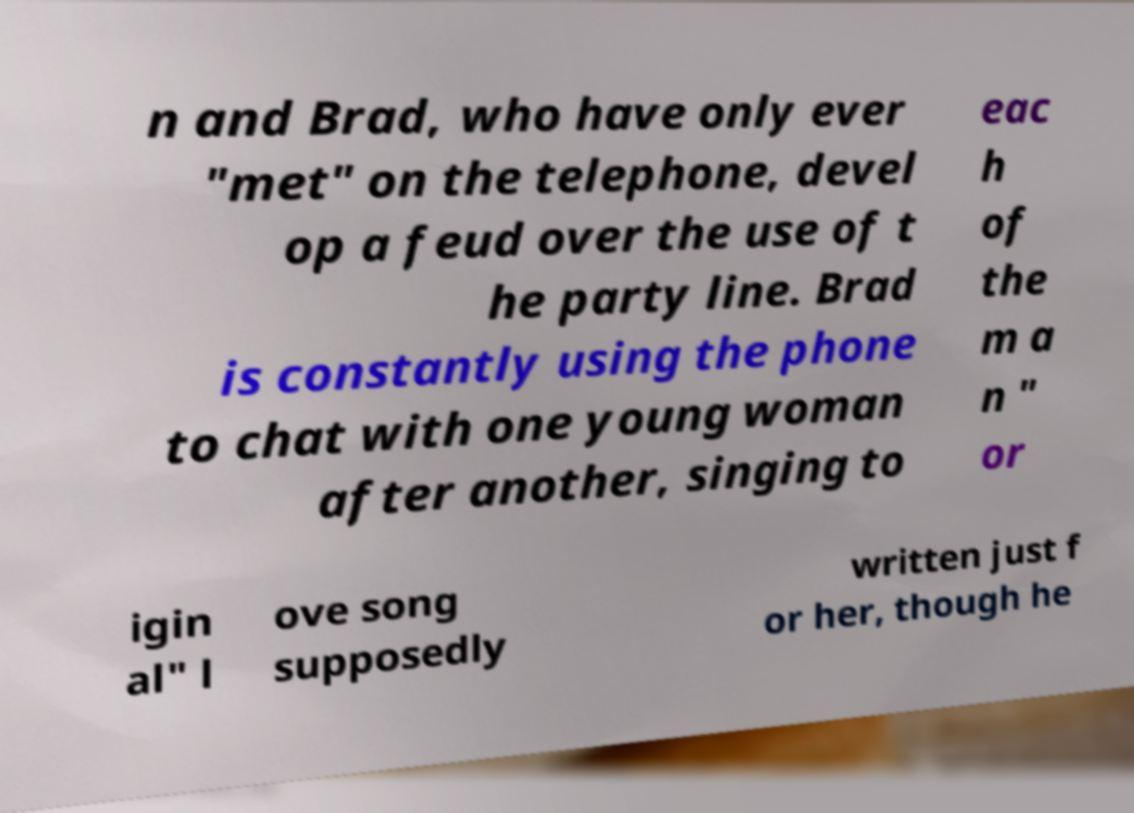Can you read and provide the text displayed in the image?This photo seems to have some interesting text. Can you extract and type it out for me? n and Brad, who have only ever "met" on the telephone, devel op a feud over the use of t he party line. Brad is constantly using the phone to chat with one young woman after another, singing to eac h of the m a n " or igin al" l ove song supposedly written just f or her, though he 